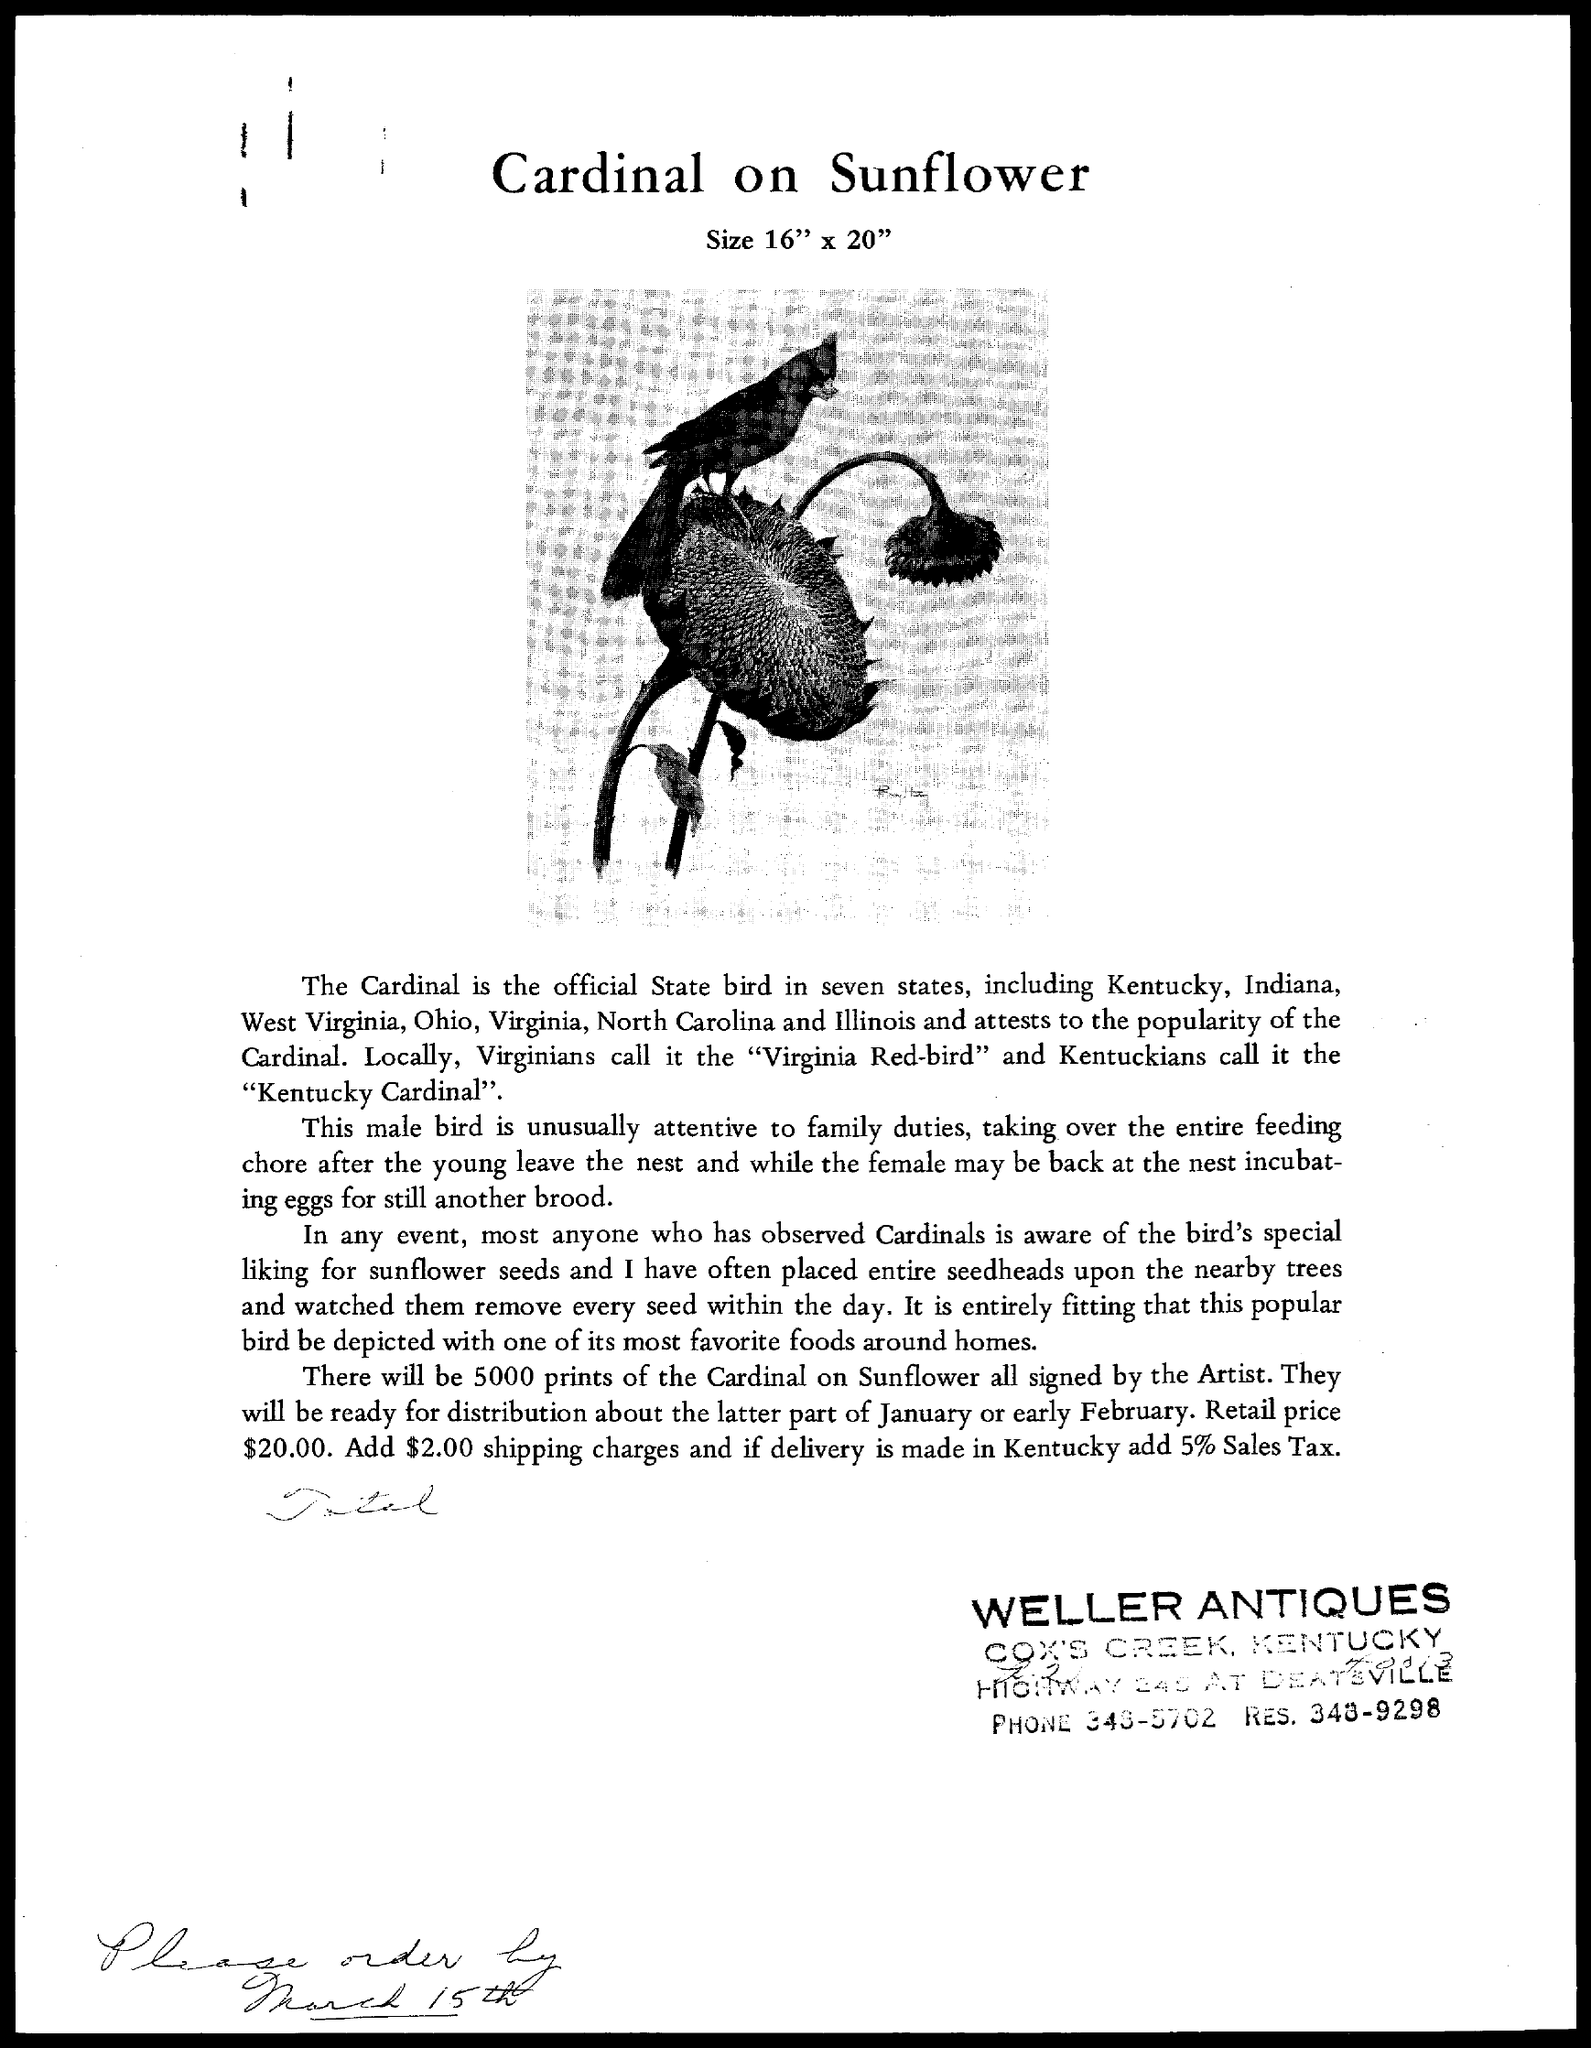Mention a couple of crucial points in this snapshot. The document is titled 'Cardinal on Sunflower.' 